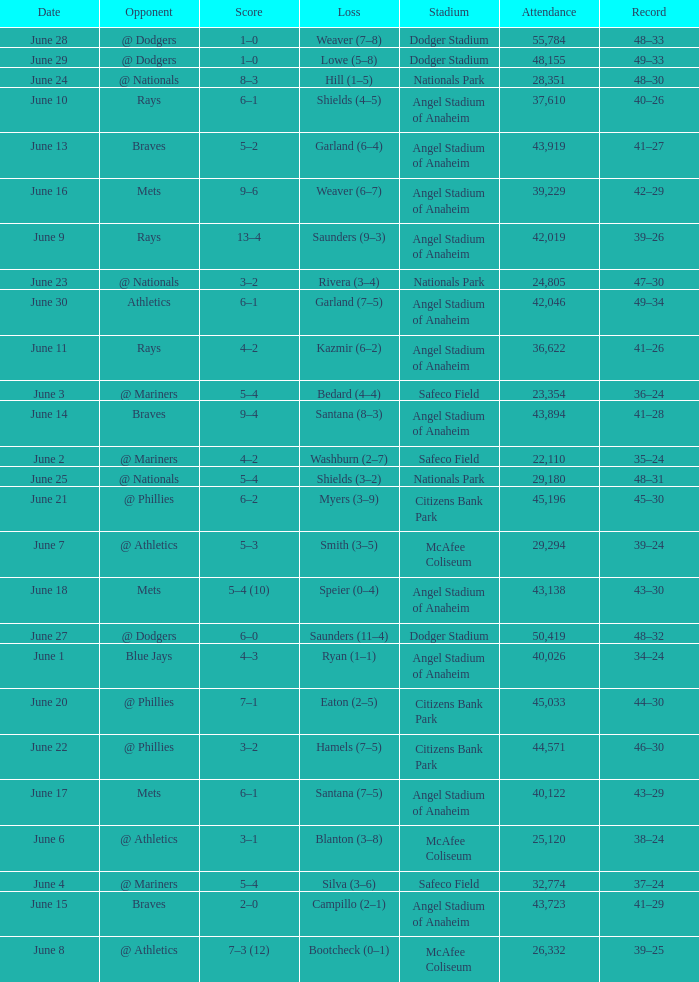What was the score of the game against the Braves with a record of 41–27? 5–2. 